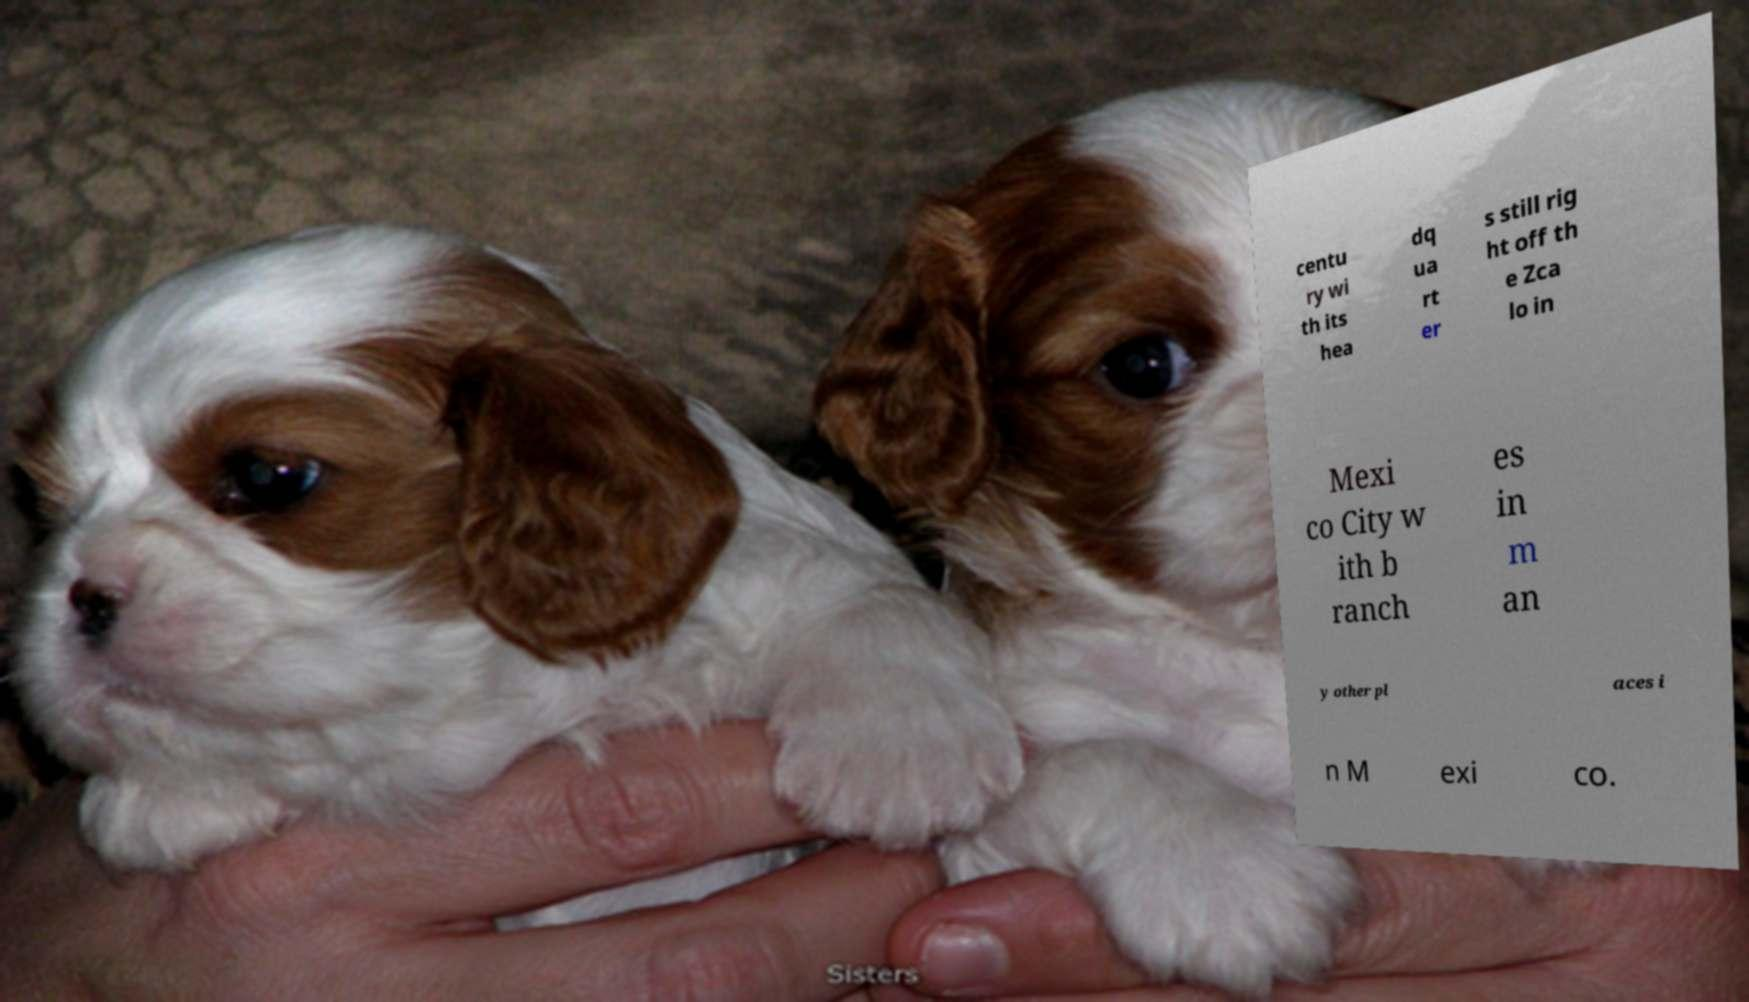For documentation purposes, I need the text within this image transcribed. Could you provide that? centu ry wi th its hea dq ua rt er s still rig ht off th e Zca lo in Mexi co City w ith b ranch es in m an y other pl aces i n M exi co. 